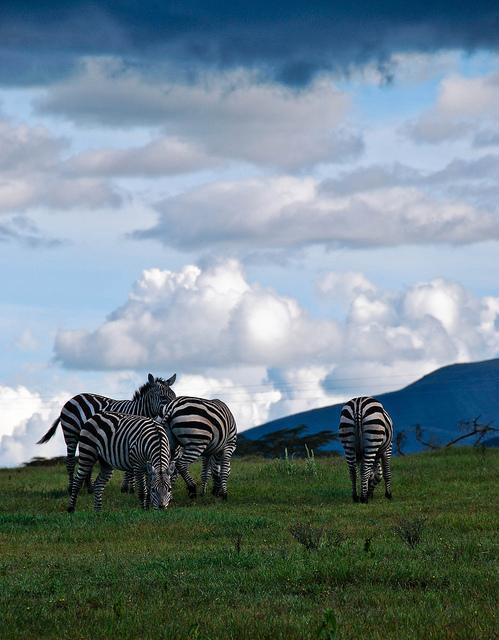How many birds are seen?
Give a very brief answer. 0. How many zebras are there?
Give a very brief answer. 4. How many birds are looking at the camera?
Give a very brief answer. 0. 